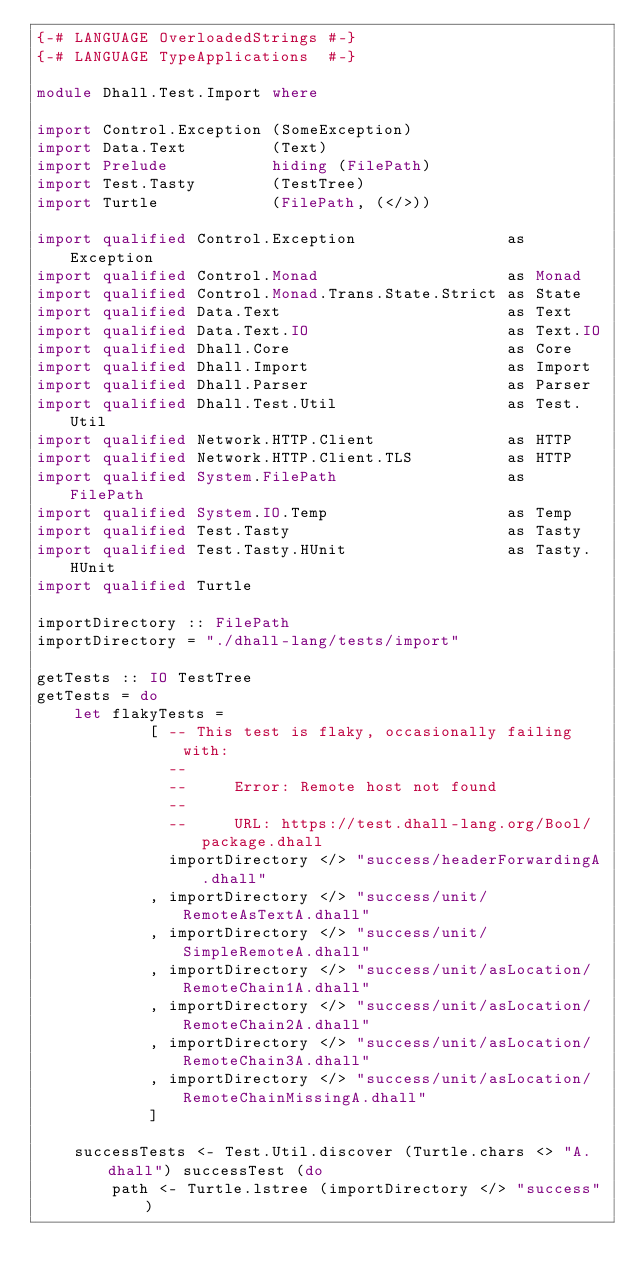Convert code to text. <code><loc_0><loc_0><loc_500><loc_500><_Haskell_>{-# LANGUAGE OverloadedStrings #-}
{-# LANGUAGE TypeApplications  #-}

module Dhall.Test.Import where

import Control.Exception (SomeException)
import Data.Text         (Text)
import Prelude           hiding (FilePath)
import Test.Tasty        (TestTree)
import Turtle            (FilePath, (</>))

import qualified Control.Exception                as Exception
import qualified Control.Monad                    as Monad
import qualified Control.Monad.Trans.State.Strict as State
import qualified Data.Text                        as Text
import qualified Data.Text.IO                     as Text.IO
import qualified Dhall.Core                       as Core
import qualified Dhall.Import                     as Import
import qualified Dhall.Parser                     as Parser
import qualified Dhall.Test.Util                  as Test.Util
import qualified Network.HTTP.Client              as HTTP
import qualified Network.HTTP.Client.TLS          as HTTP
import qualified System.FilePath                  as FilePath
import qualified System.IO.Temp                   as Temp
import qualified Test.Tasty                       as Tasty
import qualified Test.Tasty.HUnit                 as Tasty.HUnit
import qualified Turtle

importDirectory :: FilePath
importDirectory = "./dhall-lang/tests/import"

getTests :: IO TestTree
getTests = do
    let flakyTests =
            [ -- This test is flaky, occasionally failing with:
              --
              --     Error: Remote host not found
              --
              --     URL: https://test.dhall-lang.org/Bool/package.dhall
              importDirectory </> "success/headerForwardingA.dhall"
            , importDirectory </> "success/unit/RemoteAsTextA.dhall"
            , importDirectory </> "success/unit/SimpleRemoteA.dhall"
            , importDirectory </> "success/unit/asLocation/RemoteChain1A.dhall"
            , importDirectory </> "success/unit/asLocation/RemoteChain2A.dhall"
            , importDirectory </> "success/unit/asLocation/RemoteChain3A.dhall"
            , importDirectory </> "success/unit/asLocation/RemoteChainMissingA.dhall"
            ]

    successTests <- Test.Util.discover (Turtle.chars <> "A.dhall") successTest (do
        path <- Turtle.lstree (importDirectory </> "success")
</code> 